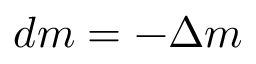Convert formula to latex. <formula><loc_0><loc_0><loc_500><loc_500>d m = - \Delta m</formula> 